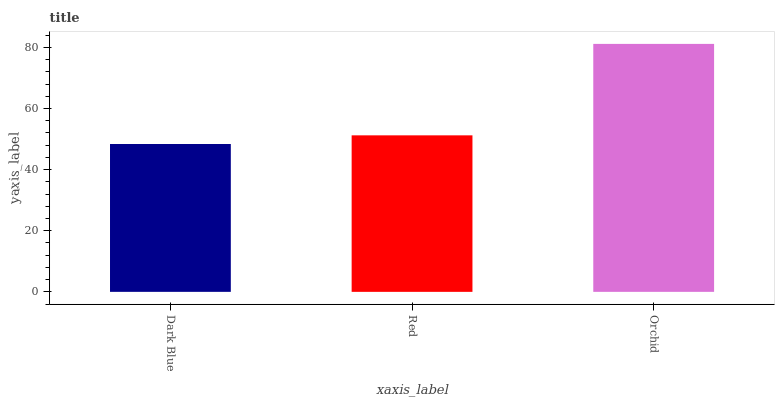Is Dark Blue the minimum?
Answer yes or no. Yes. Is Orchid the maximum?
Answer yes or no. Yes. Is Red the minimum?
Answer yes or no. No. Is Red the maximum?
Answer yes or no. No. Is Red greater than Dark Blue?
Answer yes or no. Yes. Is Dark Blue less than Red?
Answer yes or no. Yes. Is Dark Blue greater than Red?
Answer yes or no. No. Is Red less than Dark Blue?
Answer yes or no. No. Is Red the high median?
Answer yes or no. Yes. Is Red the low median?
Answer yes or no. Yes. Is Orchid the high median?
Answer yes or no. No. Is Orchid the low median?
Answer yes or no. No. 